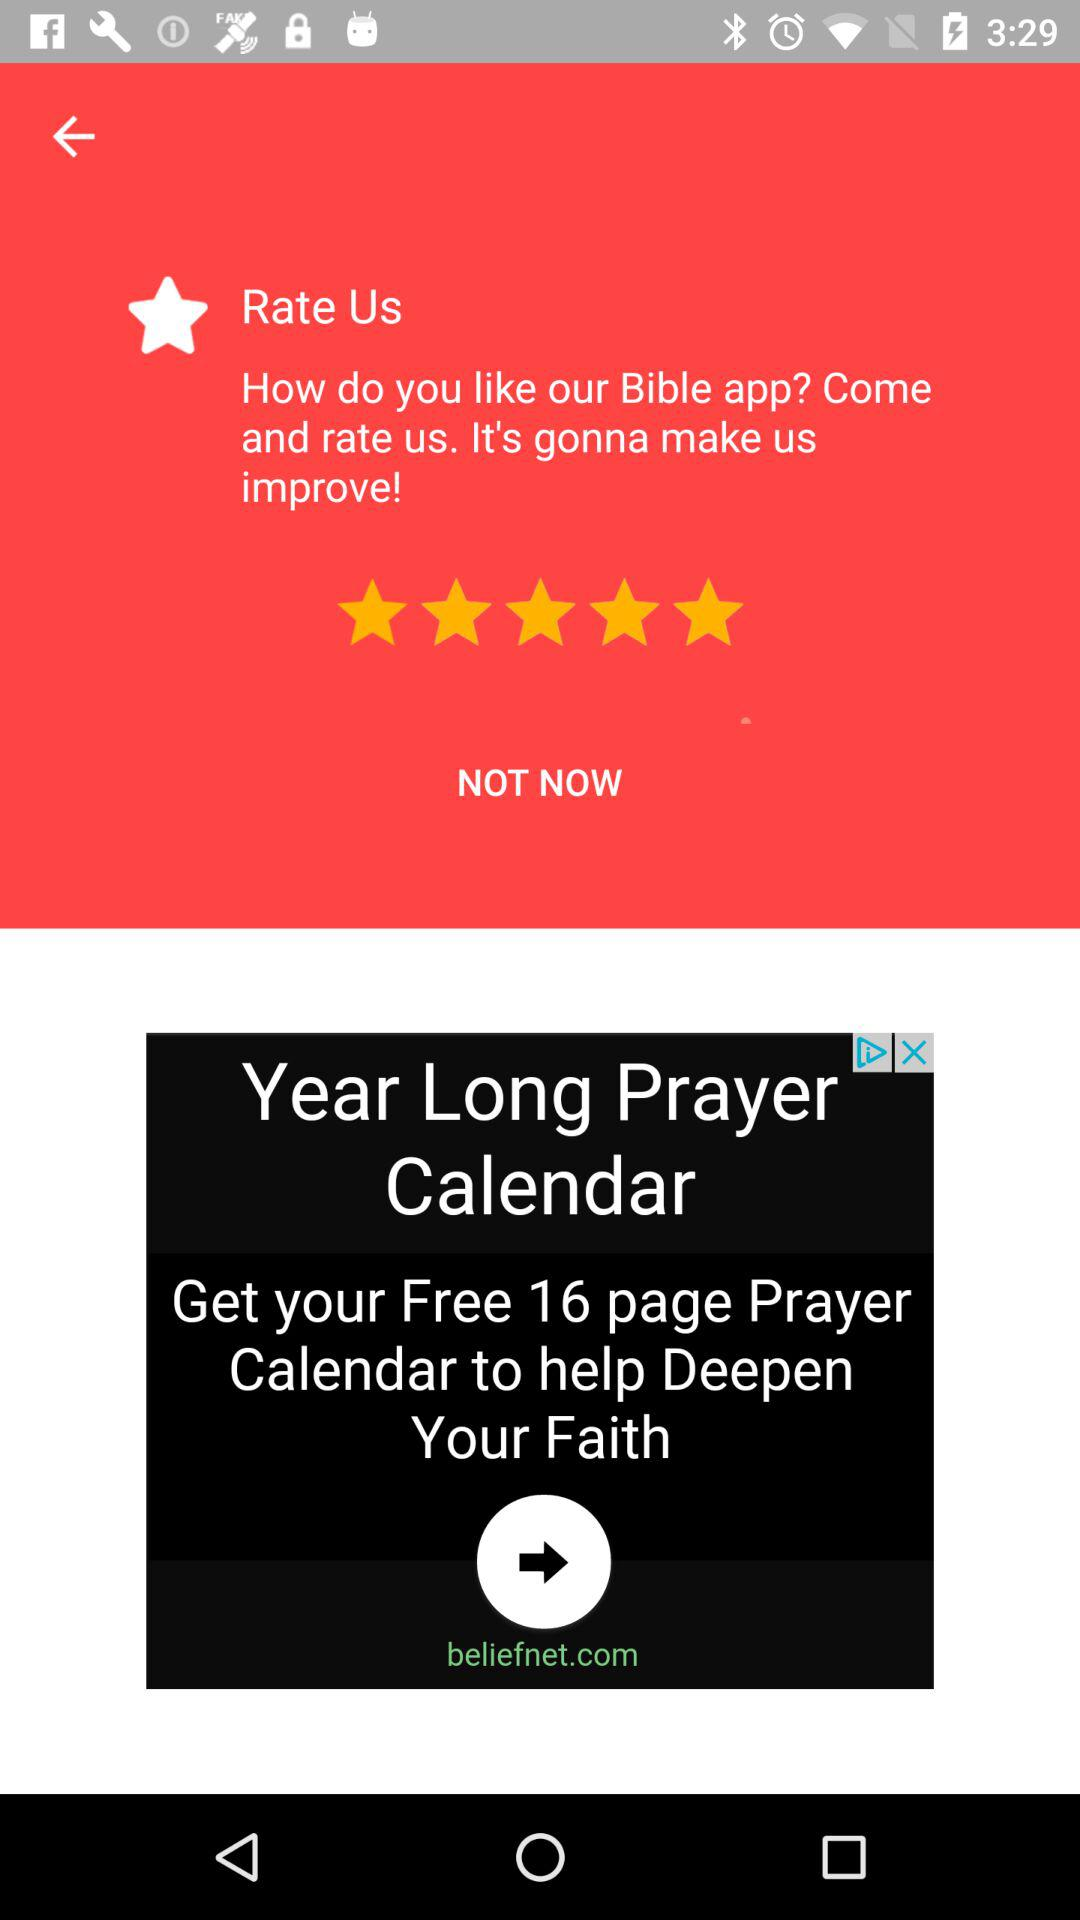What is the name of the application? The name of the application is "Bible". 